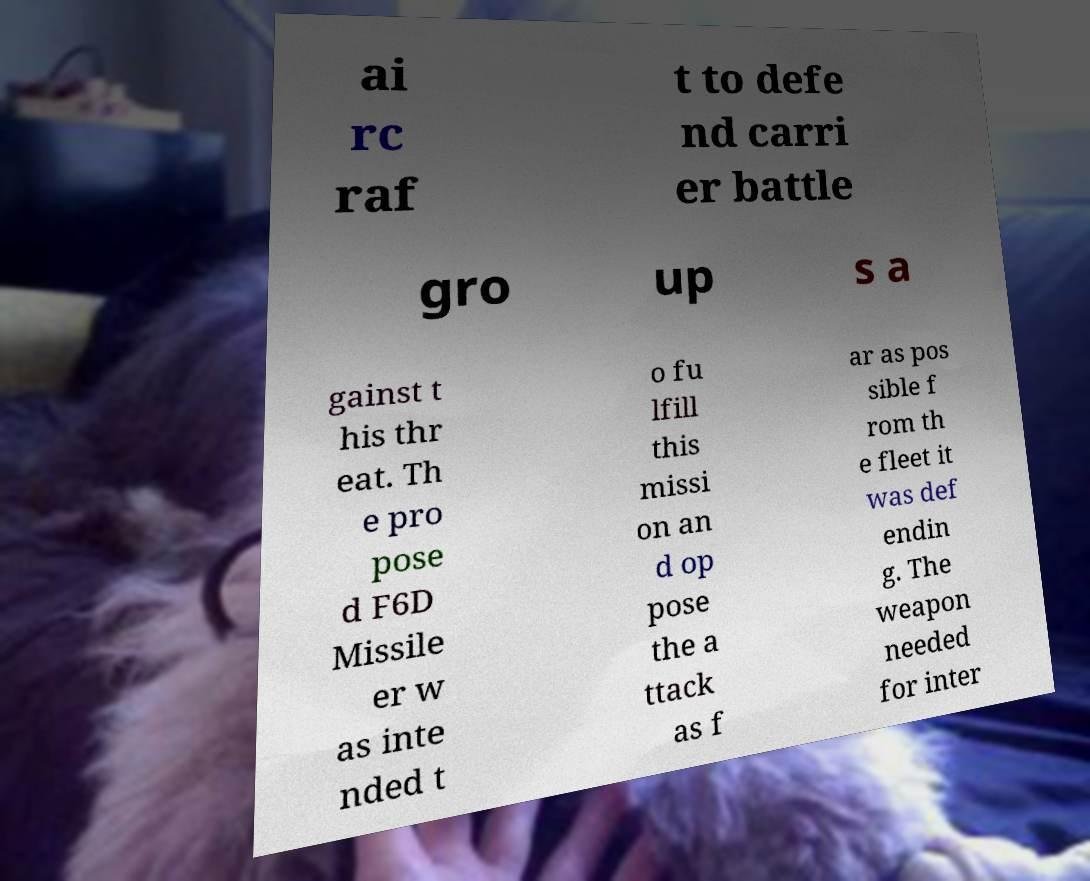For documentation purposes, I need the text within this image transcribed. Could you provide that? ai rc raf t to defe nd carri er battle gro up s a gainst t his thr eat. Th e pro pose d F6D Missile er w as inte nded t o fu lfill this missi on an d op pose the a ttack as f ar as pos sible f rom th e fleet it was def endin g. The weapon needed for inter 